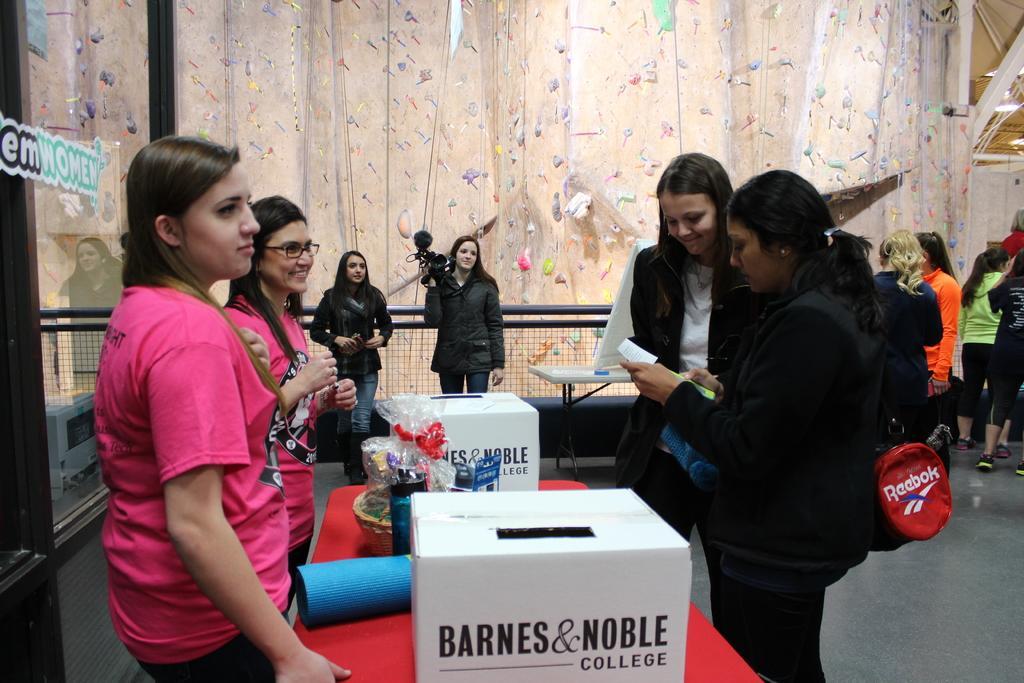Please provide a concise description of this image. In this image we can see a few people standing, among them some people are holding the objects, also we can see a table, on the table, there are boxes and some other objects. In the background, we can see the fence and the wall, on the left side of the image we can see a glass with some text on it. 